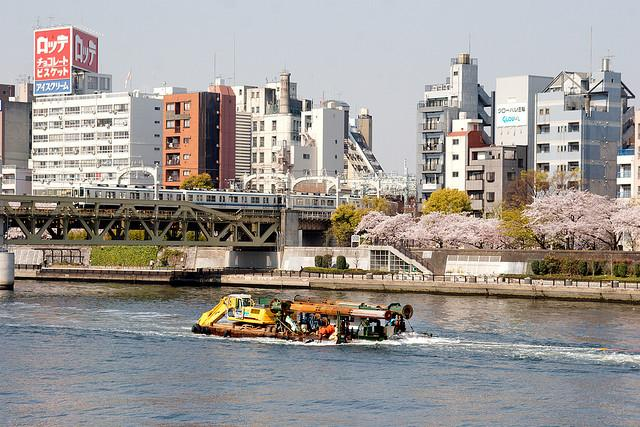What type of area is nearby? Please explain your reasoning. urban. There are buildings and trains nearby. the trees are not palm trees. 